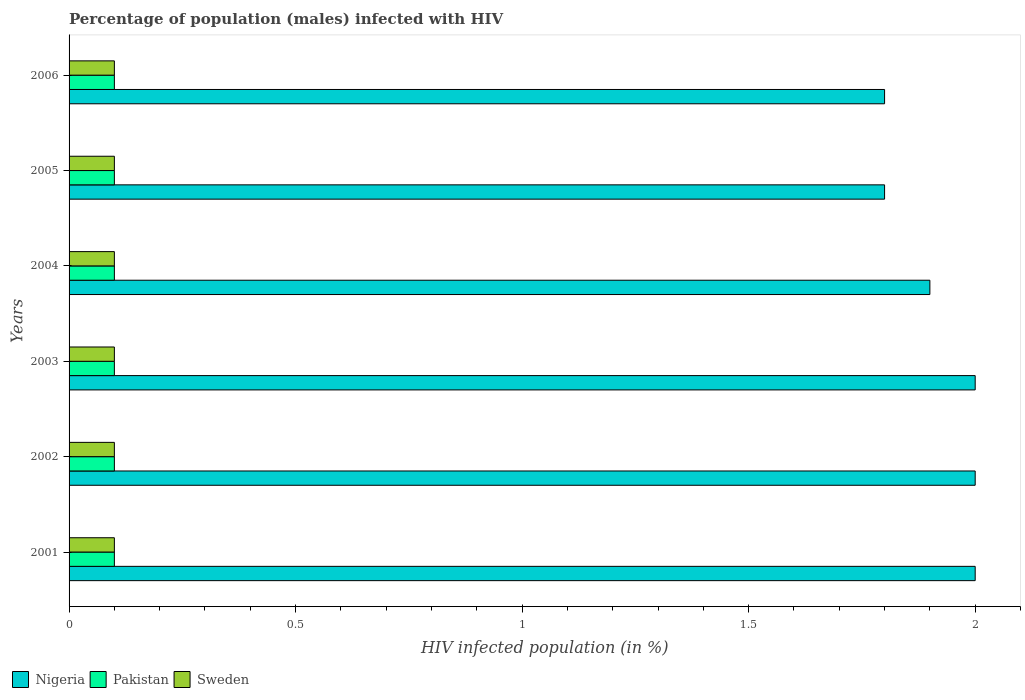How many groups of bars are there?
Provide a short and direct response. 6. Are the number of bars per tick equal to the number of legend labels?
Your answer should be very brief. Yes. How many bars are there on the 1st tick from the top?
Offer a terse response. 3. What is the label of the 1st group of bars from the top?
Offer a very short reply. 2006. In how many cases, is the number of bars for a given year not equal to the number of legend labels?
Ensure brevity in your answer.  0. What is the percentage of HIV infected male population in Sweden in 2002?
Offer a very short reply. 0.1. Across all years, what is the maximum percentage of HIV infected male population in Nigeria?
Your answer should be very brief. 2. Across all years, what is the minimum percentage of HIV infected male population in Pakistan?
Provide a short and direct response. 0.1. In which year was the percentage of HIV infected male population in Pakistan maximum?
Ensure brevity in your answer.  2001. In which year was the percentage of HIV infected male population in Sweden minimum?
Make the answer very short. 2001. What is the total percentage of HIV infected male population in Nigeria in the graph?
Offer a terse response. 11.5. What is the difference between the percentage of HIV infected male population in Nigeria in 2001 and that in 2004?
Offer a terse response. 0.1. What is the average percentage of HIV infected male population in Sweden per year?
Keep it short and to the point. 0.1. What is the ratio of the percentage of HIV infected male population in Sweden in 2001 to that in 2002?
Offer a terse response. 1. Is the difference between the percentage of HIV infected male population in Nigeria in 2001 and 2002 greater than the difference between the percentage of HIV infected male population in Pakistan in 2001 and 2002?
Your answer should be very brief. No. In how many years, is the percentage of HIV infected male population in Pakistan greater than the average percentage of HIV infected male population in Pakistan taken over all years?
Your response must be concise. 6. Is the sum of the percentage of HIV infected male population in Nigeria in 2002 and 2004 greater than the maximum percentage of HIV infected male population in Sweden across all years?
Provide a short and direct response. Yes. What does the 1st bar from the bottom in 2004 represents?
Offer a terse response. Nigeria. Is it the case that in every year, the sum of the percentage of HIV infected male population in Nigeria and percentage of HIV infected male population in Pakistan is greater than the percentage of HIV infected male population in Sweden?
Make the answer very short. Yes. How many bars are there?
Make the answer very short. 18. Are all the bars in the graph horizontal?
Offer a very short reply. Yes. How many years are there in the graph?
Your answer should be very brief. 6. What is the difference between two consecutive major ticks on the X-axis?
Offer a terse response. 0.5. Does the graph contain any zero values?
Your response must be concise. No. Where does the legend appear in the graph?
Offer a terse response. Bottom left. How are the legend labels stacked?
Keep it short and to the point. Horizontal. What is the title of the graph?
Keep it short and to the point. Percentage of population (males) infected with HIV. Does "Armenia" appear as one of the legend labels in the graph?
Offer a very short reply. No. What is the label or title of the X-axis?
Provide a short and direct response. HIV infected population (in %). What is the label or title of the Y-axis?
Your answer should be very brief. Years. What is the HIV infected population (in %) in Pakistan in 2001?
Your answer should be very brief. 0.1. What is the HIV infected population (in %) of Sweden in 2001?
Your answer should be very brief. 0.1. What is the HIV infected population (in %) in Nigeria in 2002?
Provide a succinct answer. 2. What is the HIV infected population (in %) of Sweden in 2002?
Ensure brevity in your answer.  0.1. What is the HIV infected population (in %) in Pakistan in 2003?
Offer a terse response. 0.1. What is the HIV infected population (in %) in Pakistan in 2004?
Keep it short and to the point. 0.1. What is the HIV infected population (in %) of Nigeria in 2005?
Your answer should be compact. 1.8. What is the HIV infected population (in %) in Pakistan in 2006?
Keep it short and to the point. 0.1. What is the HIV infected population (in %) in Sweden in 2006?
Provide a short and direct response. 0.1. Across all years, what is the maximum HIV infected population (in %) in Nigeria?
Give a very brief answer. 2. Across all years, what is the maximum HIV infected population (in %) in Sweden?
Provide a succinct answer. 0.1. Across all years, what is the minimum HIV infected population (in %) of Nigeria?
Provide a short and direct response. 1.8. Across all years, what is the minimum HIV infected population (in %) of Pakistan?
Provide a short and direct response. 0.1. Across all years, what is the minimum HIV infected population (in %) in Sweden?
Ensure brevity in your answer.  0.1. What is the total HIV infected population (in %) in Nigeria in the graph?
Your answer should be compact. 11.5. What is the total HIV infected population (in %) in Sweden in the graph?
Offer a very short reply. 0.6. What is the difference between the HIV infected population (in %) in Nigeria in 2001 and that in 2002?
Offer a very short reply. 0. What is the difference between the HIV infected population (in %) of Pakistan in 2001 and that in 2002?
Offer a terse response. 0. What is the difference between the HIV infected population (in %) in Nigeria in 2001 and that in 2003?
Keep it short and to the point. 0. What is the difference between the HIV infected population (in %) in Pakistan in 2001 and that in 2003?
Your answer should be compact. 0. What is the difference between the HIV infected population (in %) of Sweden in 2001 and that in 2003?
Keep it short and to the point. 0. What is the difference between the HIV infected population (in %) in Nigeria in 2001 and that in 2004?
Your answer should be very brief. 0.1. What is the difference between the HIV infected population (in %) of Pakistan in 2001 and that in 2004?
Offer a terse response. 0. What is the difference between the HIV infected population (in %) in Sweden in 2001 and that in 2004?
Keep it short and to the point. 0. What is the difference between the HIV infected population (in %) in Nigeria in 2001 and that in 2005?
Ensure brevity in your answer.  0.2. What is the difference between the HIV infected population (in %) in Pakistan in 2001 and that in 2006?
Your response must be concise. 0. What is the difference between the HIV infected population (in %) in Pakistan in 2002 and that in 2003?
Ensure brevity in your answer.  0. What is the difference between the HIV infected population (in %) in Nigeria in 2002 and that in 2005?
Make the answer very short. 0.2. What is the difference between the HIV infected population (in %) of Sweden in 2002 and that in 2005?
Offer a very short reply. 0. What is the difference between the HIV infected population (in %) in Nigeria in 2002 and that in 2006?
Offer a very short reply. 0.2. What is the difference between the HIV infected population (in %) of Pakistan in 2002 and that in 2006?
Your answer should be compact. 0. What is the difference between the HIV infected population (in %) of Pakistan in 2003 and that in 2004?
Give a very brief answer. 0. What is the difference between the HIV infected population (in %) of Sweden in 2003 and that in 2004?
Provide a succinct answer. 0. What is the difference between the HIV infected population (in %) in Nigeria in 2003 and that in 2005?
Your answer should be very brief. 0.2. What is the difference between the HIV infected population (in %) in Nigeria in 2003 and that in 2006?
Offer a terse response. 0.2. What is the difference between the HIV infected population (in %) of Pakistan in 2003 and that in 2006?
Your answer should be compact. 0. What is the difference between the HIV infected population (in %) in Sweden in 2004 and that in 2006?
Provide a short and direct response. 0. What is the difference between the HIV infected population (in %) of Pakistan in 2005 and that in 2006?
Keep it short and to the point. 0. What is the difference between the HIV infected population (in %) in Sweden in 2005 and that in 2006?
Your answer should be very brief. 0. What is the difference between the HIV infected population (in %) in Nigeria in 2001 and the HIV infected population (in %) in Pakistan in 2002?
Ensure brevity in your answer.  1.9. What is the difference between the HIV infected population (in %) of Pakistan in 2001 and the HIV infected population (in %) of Sweden in 2002?
Your answer should be very brief. 0. What is the difference between the HIV infected population (in %) in Nigeria in 2001 and the HIV infected population (in %) in Pakistan in 2003?
Your answer should be compact. 1.9. What is the difference between the HIV infected population (in %) in Nigeria in 2001 and the HIV infected population (in %) in Pakistan in 2004?
Your answer should be compact. 1.9. What is the difference between the HIV infected population (in %) in Pakistan in 2001 and the HIV infected population (in %) in Sweden in 2004?
Ensure brevity in your answer.  0. What is the difference between the HIV infected population (in %) in Nigeria in 2001 and the HIV infected population (in %) in Pakistan in 2005?
Keep it short and to the point. 1.9. What is the difference between the HIV infected population (in %) in Nigeria in 2001 and the HIV infected population (in %) in Sweden in 2005?
Make the answer very short. 1.9. What is the difference between the HIV infected population (in %) in Pakistan in 2001 and the HIV infected population (in %) in Sweden in 2005?
Your answer should be compact. 0. What is the difference between the HIV infected population (in %) of Nigeria in 2001 and the HIV infected population (in %) of Pakistan in 2006?
Make the answer very short. 1.9. What is the difference between the HIV infected population (in %) in Nigeria in 2001 and the HIV infected population (in %) in Sweden in 2006?
Provide a succinct answer. 1.9. What is the difference between the HIV infected population (in %) of Nigeria in 2002 and the HIV infected population (in %) of Sweden in 2003?
Ensure brevity in your answer.  1.9. What is the difference between the HIV infected population (in %) in Pakistan in 2002 and the HIV infected population (in %) in Sweden in 2003?
Offer a terse response. 0. What is the difference between the HIV infected population (in %) in Pakistan in 2002 and the HIV infected population (in %) in Sweden in 2004?
Your response must be concise. 0. What is the difference between the HIV infected population (in %) of Nigeria in 2002 and the HIV infected population (in %) of Pakistan in 2005?
Ensure brevity in your answer.  1.9. What is the difference between the HIV infected population (in %) of Nigeria in 2002 and the HIV infected population (in %) of Sweden in 2005?
Offer a very short reply. 1.9. What is the difference between the HIV infected population (in %) of Nigeria in 2002 and the HIV infected population (in %) of Pakistan in 2006?
Provide a succinct answer. 1.9. What is the difference between the HIV infected population (in %) of Nigeria in 2002 and the HIV infected population (in %) of Sweden in 2006?
Offer a very short reply. 1.9. What is the difference between the HIV infected population (in %) in Pakistan in 2003 and the HIV infected population (in %) in Sweden in 2004?
Provide a succinct answer. 0. What is the difference between the HIV infected population (in %) of Nigeria in 2003 and the HIV infected population (in %) of Pakistan in 2005?
Offer a very short reply. 1.9. What is the difference between the HIV infected population (in %) in Pakistan in 2003 and the HIV infected population (in %) in Sweden in 2005?
Provide a short and direct response. 0. What is the difference between the HIV infected population (in %) in Nigeria in 2003 and the HIV infected population (in %) in Sweden in 2006?
Your response must be concise. 1.9. What is the difference between the HIV infected population (in %) in Pakistan in 2003 and the HIV infected population (in %) in Sweden in 2006?
Your answer should be very brief. 0. What is the difference between the HIV infected population (in %) in Pakistan in 2004 and the HIV infected population (in %) in Sweden in 2005?
Keep it short and to the point. 0. What is the difference between the HIV infected population (in %) of Nigeria in 2004 and the HIV infected population (in %) of Pakistan in 2006?
Make the answer very short. 1.8. What is the difference between the HIV infected population (in %) in Nigeria in 2004 and the HIV infected population (in %) in Sweden in 2006?
Provide a succinct answer. 1.8. What is the average HIV infected population (in %) in Nigeria per year?
Give a very brief answer. 1.92. In the year 2001, what is the difference between the HIV infected population (in %) of Nigeria and HIV infected population (in %) of Pakistan?
Keep it short and to the point. 1.9. In the year 2001, what is the difference between the HIV infected population (in %) of Pakistan and HIV infected population (in %) of Sweden?
Your response must be concise. 0. In the year 2002, what is the difference between the HIV infected population (in %) of Nigeria and HIV infected population (in %) of Pakistan?
Your answer should be compact. 1.9. In the year 2003, what is the difference between the HIV infected population (in %) in Nigeria and HIV infected population (in %) in Pakistan?
Provide a succinct answer. 1.9. In the year 2003, what is the difference between the HIV infected population (in %) in Pakistan and HIV infected population (in %) in Sweden?
Keep it short and to the point. 0. In the year 2004, what is the difference between the HIV infected population (in %) in Nigeria and HIV infected population (in %) in Sweden?
Make the answer very short. 1.8. In the year 2004, what is the difference between the HIV infected population (in %) of Pakistan and HIV infected population (in %) of Sweden?
Provide a succinct answer. 0. In the year 2005, what is the difference between the HIV infected population (in %) in Nigeria and HIV infected population (in %) in Pakistan?
Provide a short and direct response. 1.7. In the year 2005, what is the difference between the HIV infected population (in %) of Pakistan and HIV infected population (in %) of Sweden?
Offer a terse response. 0. In the year 2006, what is the difference between the HIV infected population (in %) of Nigeria and HIV infected population (in %) of Sweden?
Make the answer very short. 1.7. What is the ratio of the HIV infected population (in %) in Pakistan in 2001 to that in 2002?
Your answer should be very brief. 1. What is the ratio of the HIV infected population (in %) in Sweden in 2001 to that in 2002?
Ensure brevity in your answer.  1. What is the ratio of the HIV infected population (in %) in Nigeria in 2001 to that in 2003?
Make the answer very short. 1. What is the ratio of the HIV infected population (in %) of Pakistan in 2001 to that in 2003?
Your answer should be very brief. 1. What is the ratio of the HIV infected population (in %) of Nigeria in 2001 to that in 2004?
Offer a very short reply. 1.05. What is the ratio of the HIV infected population (in %) in Nigeria in 2001 to that in 2005?
Keep it short and to the point. 1.11. What is the ratio of the HIV infected population (in %) of Sweden in 2001 to that in 2005?
Provide a short and direct response. 1. What is the ratio of the HIV infected population (in %) of Nigeria in 2002 to that in 2003?
Provide a succinct answer. 1. What is the ratio of the HIV infected population (in %) in Pakistan in 2002 to that in 2003?
Your answer should be very brief. 1. What is the ratio of the HIV infected population (in %) in Sweden in 2002 to that in 2003?
Provide a short and direct response. 1. What is the ratio of the HIV infected population (in %) of Nigeria in 2002 to that in 2004?
Your response must be concise. 1.05. What is the ratio of the HIV infected population (in %) in Sweden in 2002 to that in 2004?
Provide a short and direct response. 1. What is the ratio of the HIV infected population (in %) of Pakistan in 2002 to that in 2005?
Offer a very short reply. 1. What is the ratio of the HIV infected population (in %) in Nigeria in 2002 to that in 2006?
Provide a short and direct response. 1.11. What is the ratio of the HIV infected population (in %) in Pakistan in 2002 to that in 2006?
Your answer should be compact. 1. What is the ratio of the HIV infected population (in %) of Nigeria in 2003 to that in 2004?
Your response must be concise. 1.05. What is the ratio of the HIV infected population (in %) of Pakistan in 2003 to that in 2004?
Your answer should be very brief. 1. What is the ratio of the HIV infected population (in %) in Sweden in 2003 to that in 2004?
Provide a short and direct response. 1. What is the ratio of the HIV infected population (in %) of Sweden in 2003 to that in 2006?
Provide a short and direct response. 1. What is the ratio of the HIV infected population (in %) in Nigeria in 2004 to that in 2005?
Your response must be concise. 1.06. What is the ratio of the HIV infected population (in %) in Sweden in 2004 to that in 2005?
Provide a succinct answer. 1. What is the ratio of the HIV infected population (in %) in Nigeria in 2004 to that in 2006?
Offer a terse response. 1.06. What is the ratio of the HIV infected population (in %) of Pakistan in 2005 to that in 2006?
Offer a terse response. 1. What is the ratio of the HIV infected population (in %) in Sweden in 2005 to that in 2006?
Provide a short and direct response. 1. What is the difference between the highest and the second highest HIV infected population (in %) in Pakistan?
Keep it short and to the point. 0. What is the difference between the highest and the lowest HIV infected population (in %) in Sweden?
Your response must be concise. 0. 